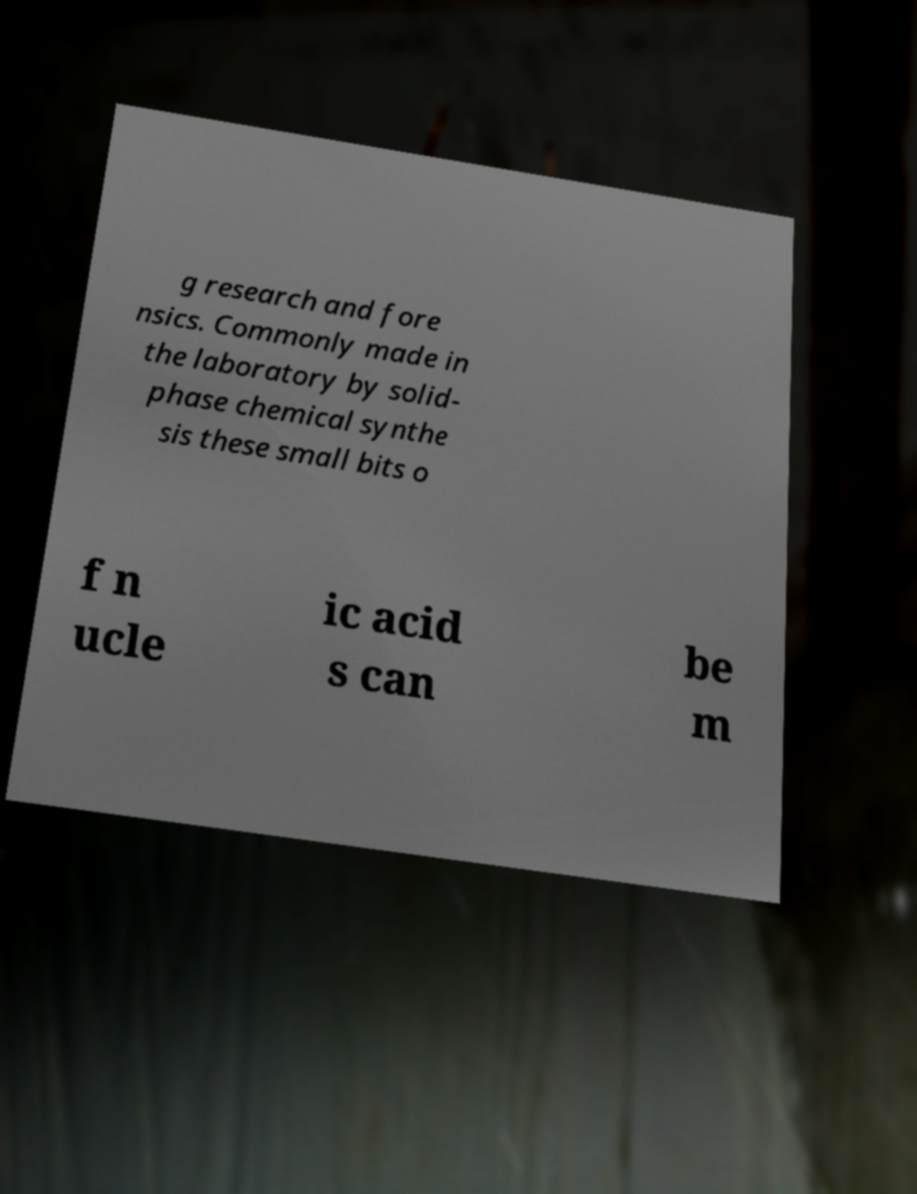What messages or text are displayed in this image? I need them in a readable, typed format. g research and fore nsics. Commonly made in the laboratory by solid- phase chemical synthe sis these small bits o f n ucle ic acid s can be m 